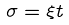Convert formula to latex. <formula><loc_0><loc_0><loc_500><loc_500>\sigma = \xi t</formula> 